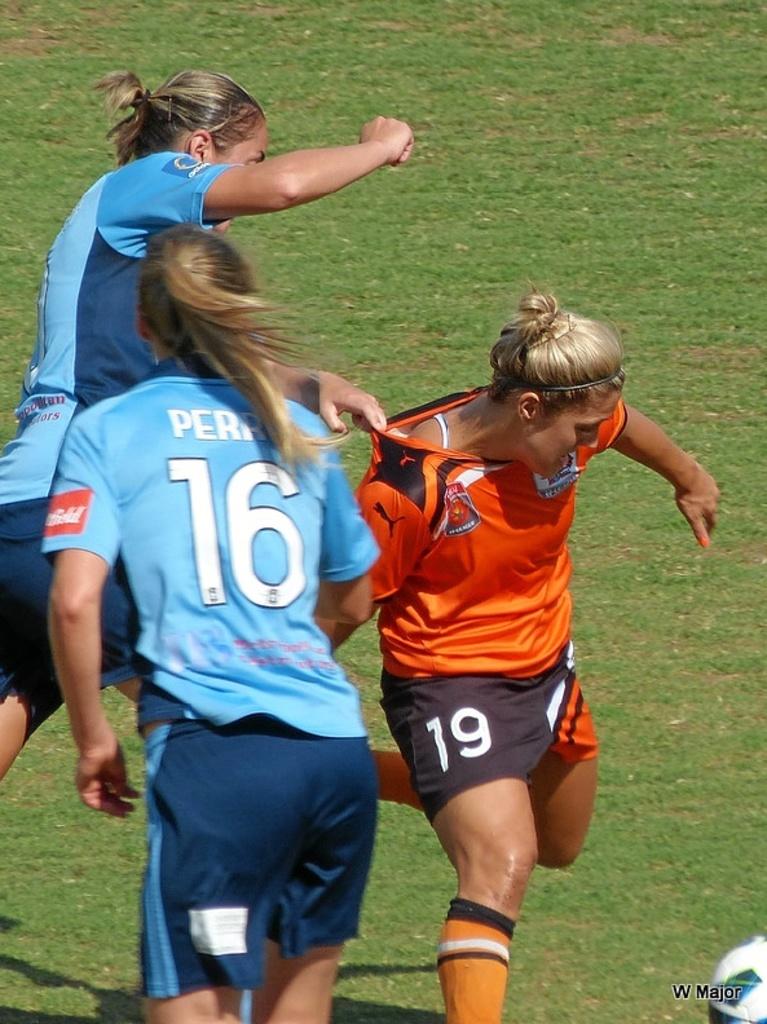What color shirt did number 16 wear?
Offer a terse response. Blue. What is the number on the shorts of the orange player?
Offer a terse response. 19. 